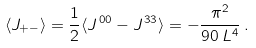<formula> <loc_0><loc_0><loc_500><loc_500>\langle J _ { + - } \rangle = \frac { 1 } { 2 } \langle J ^ { \, 0 0 } - J ^ { \, 3 3 } \rangle = - \frac { \pi ^ { 2 } } { 9 0 \, L ^ { 4 } } \, .</formula> 